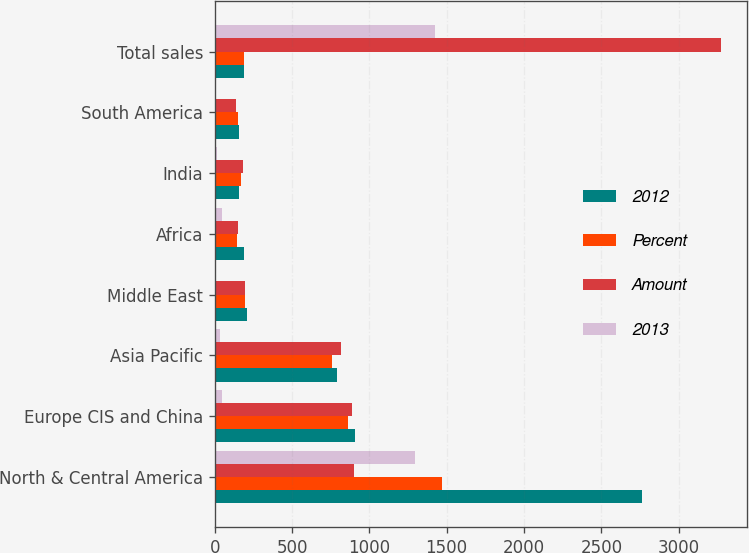Convert chart to OTSL. <chart><loc_0><loc_0><loc_500><loc_500><stacked_bar_chart><ecel><fcel>North & Central America<fcel>Europe CIS and China<fcel>Asia Pacific<fcel>Middle East<fcel>Africa<fcel>India<fcel>South America<fcel>Total sales<nl><fcel>2012<fcel>2765<fcel>908<fcel>794<fcel>208<fcel>187<fcel>157<fcel>155<fcel>190<nl><fcel>Percent<fcel>1470<fcel>862<fcel>758<fcel>198<fcel>142<fcel>170<fcel>149<fcel>190<nl><fcel>Amount<fcel>901<fcel>890<fcel>820<fcel>193<fcel>154<fcel>181<fcel>138<fcel>3277<nl><fcel>2013<fcel>1295<fcel>46<fcel>36<fcel>10<fcel>45<fcel>13<fcel>6<fcel>1425<nl></chart> 